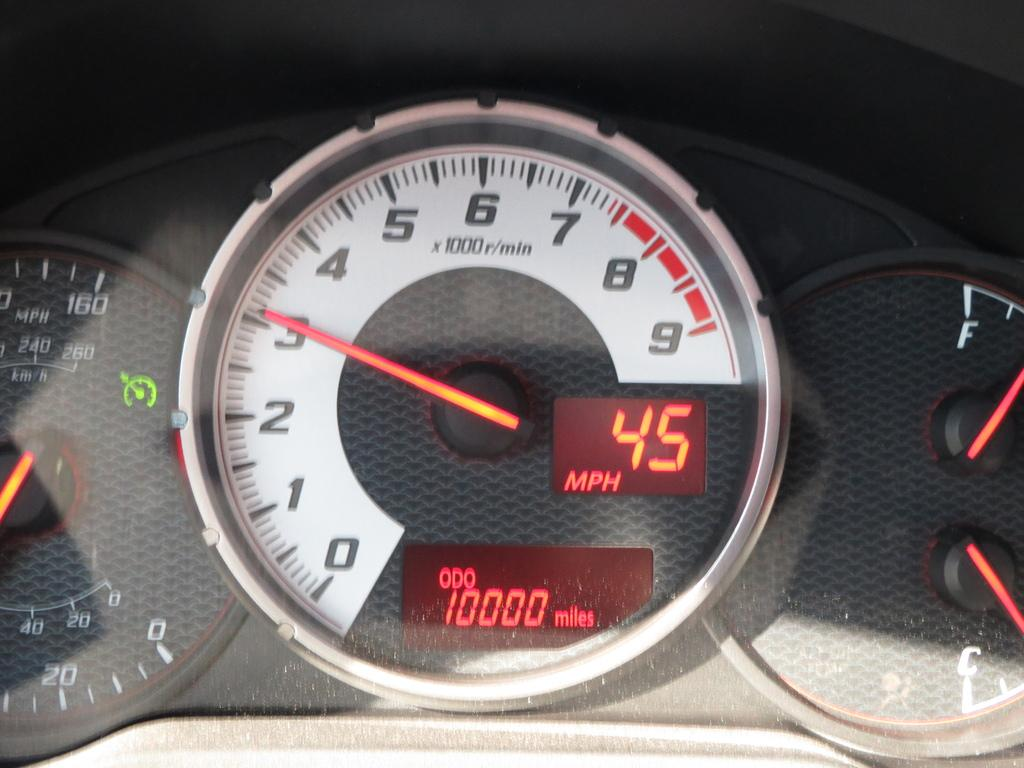What is the main object in the image? There is an odometer in the image. To which type of object does the odometer belong? The odometer belongs to a vehicle. What type of fang can be seen in the image? There is no fang present in the image; it features an odometer belonging to a vehicle. How many trains are visible in the image? There are no trains visible in the image; it features an odometer belonging to a vehicle. 